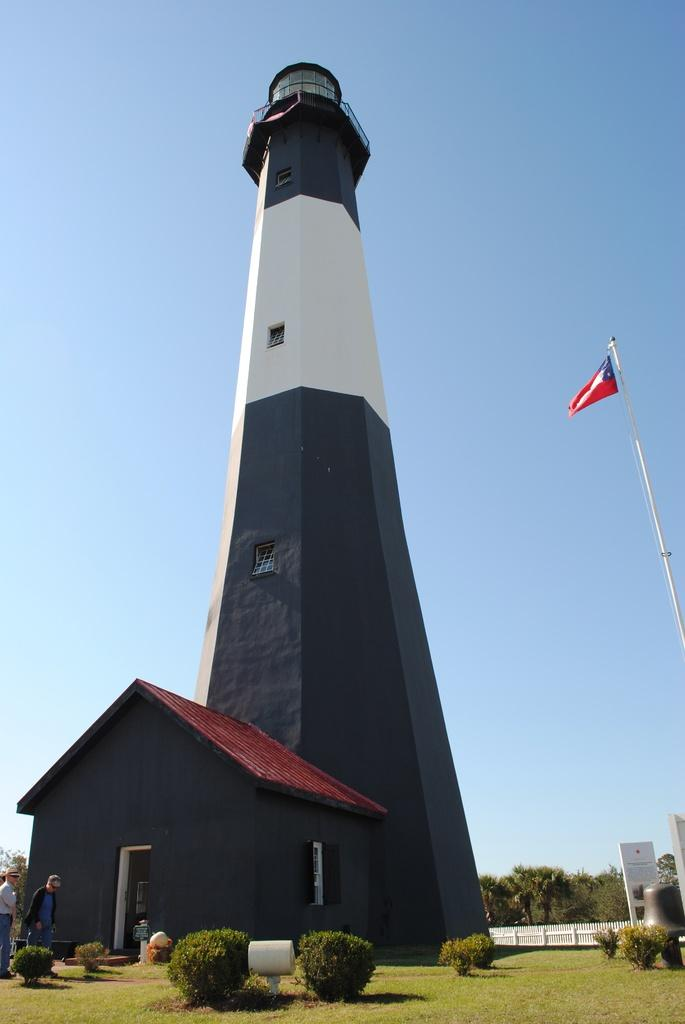What type of structure can be seen in the image? There is a building and a house in the image. Who or what is present in the image? There are people in the image. What type of natural environment is visible in the image? There is grass, plants, and trees visible in the image. What part of the natural environment is visible in the image? The sky is visible in the image. What type of society is depicted in the image? The image does not depict a society; it shows a building, a house, people, and natural elements. How does the friction between the grass and the trees affect the image? There is no mention of friction between the grass and the trees in the image; the image simply shows these elements coexisting. 